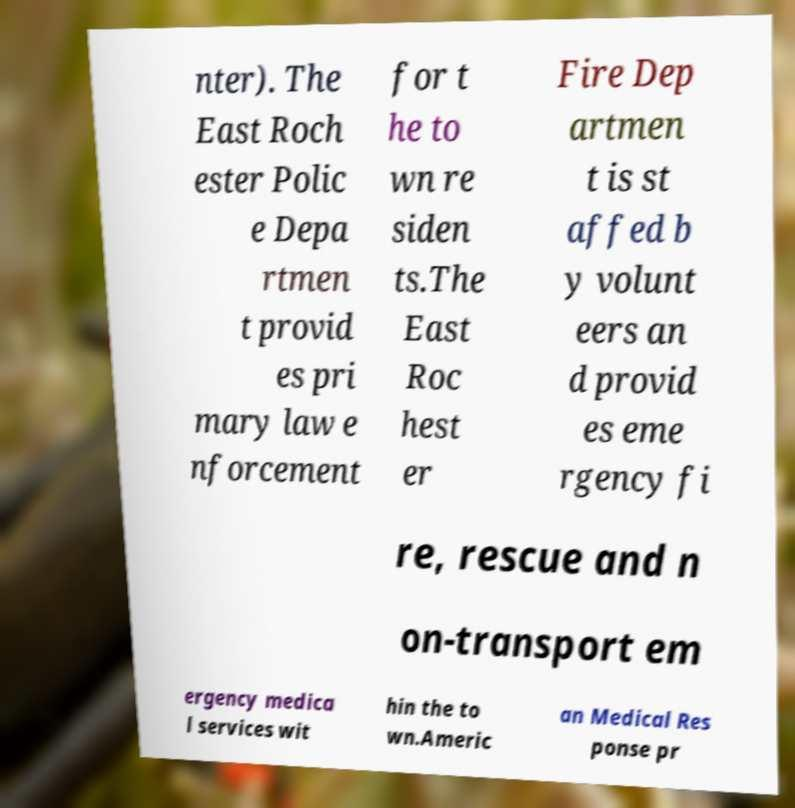Can you read and provide the text displayed in the image?This photo seems to have some interesting text. Can you extract and type it out for me? nter). The East Roch ester Polic e Depa rtmen t provid es pri mary law e nforcement for t he to wn re siden ts.The East Roc hest er Fire Dep artmen t is st affed b y volunt eers an d provid es eme rgency fi re, rescue and n on-transport em ergency medica l services wit hin the to wn.Americ an Medical Res ponse pr 